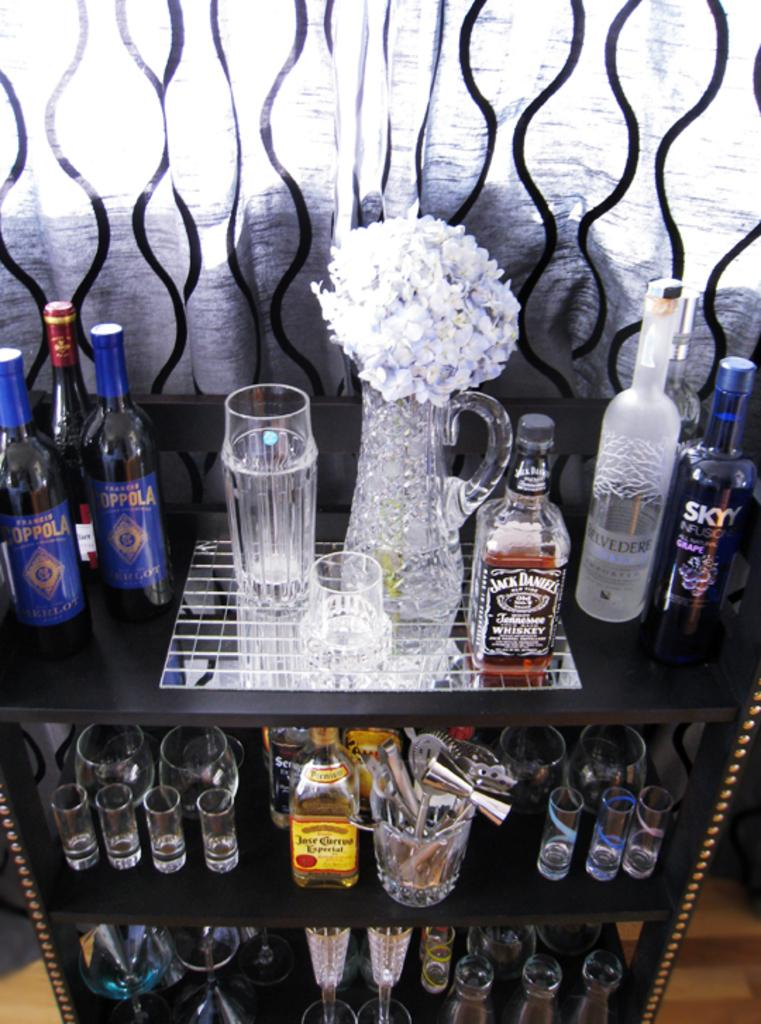What type of furniture is present in the image? There is a table in the image. What objects are placed on the table? There are glasses, bottles, and a flowers vase on the table. What type of religion is being practiced in the image? There is no indication of any religious practice in the image, as it only features a table with glasses, bottles, and a flowers vase. Can you see any yams on the table in the image? There are no yams present in the image; it only features a table with glasses, bottles, and a flowers vase. 